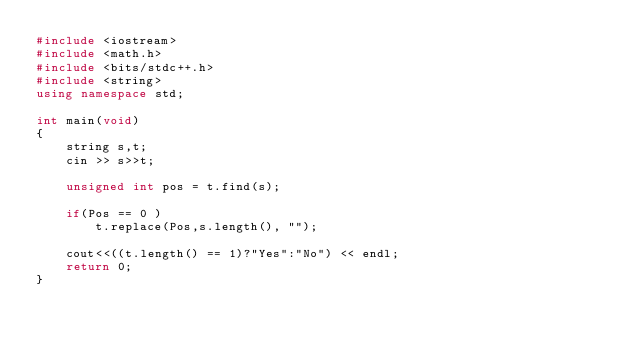<code> <loc_0><loc_0><loc_500><loc_500><_C++_>#include <iostream>
#include <math.h>
#include <bits/stdc++.h>
#include <string>
using namespace std;

int main(void)
{
    string s,t;
    cin >> s>>t;
    
    unsigned int pos = t.find(s);
    
    if(Pos == 0 )
        t.replace(Pos,s.length(), "");

    cout<<((t.length() == 1)?"Yes":"No") << endl;
    return 0;
}
</code> 